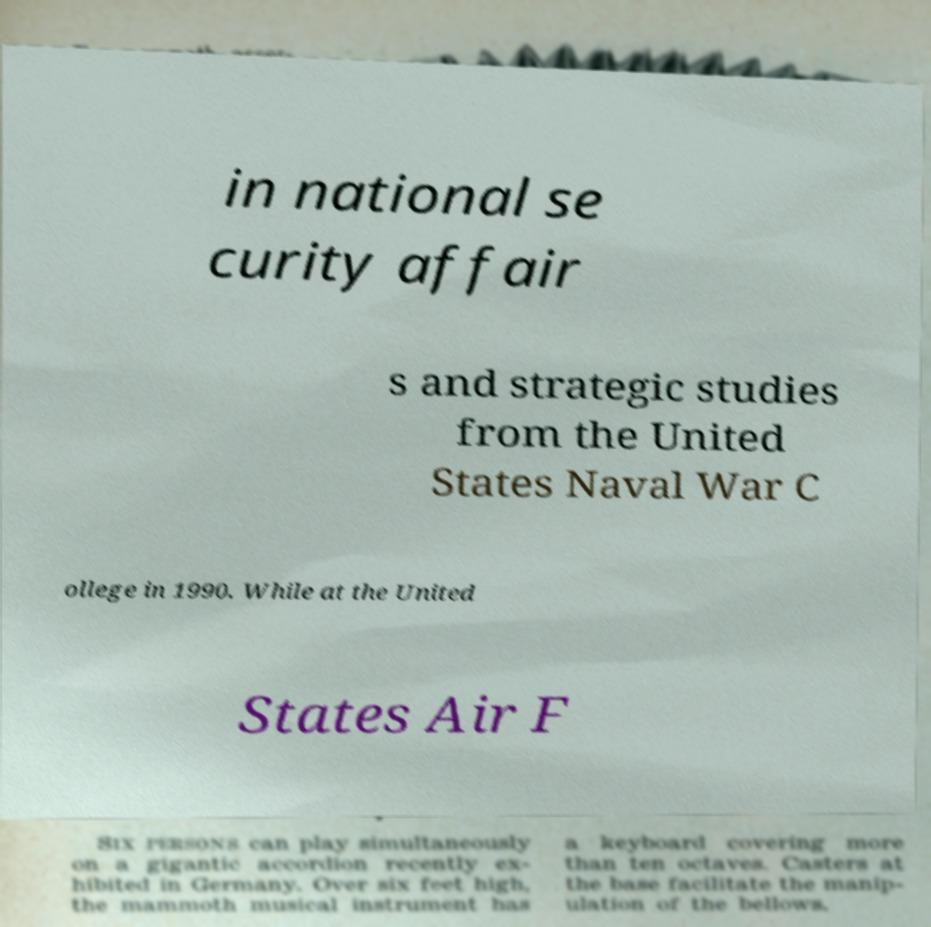What messages or text are displayed in this image? I need them in a readable, typed format. in national se curity affair s and strategic studies from the United States Naval War C ollege in 1990. While at the United States Air F 